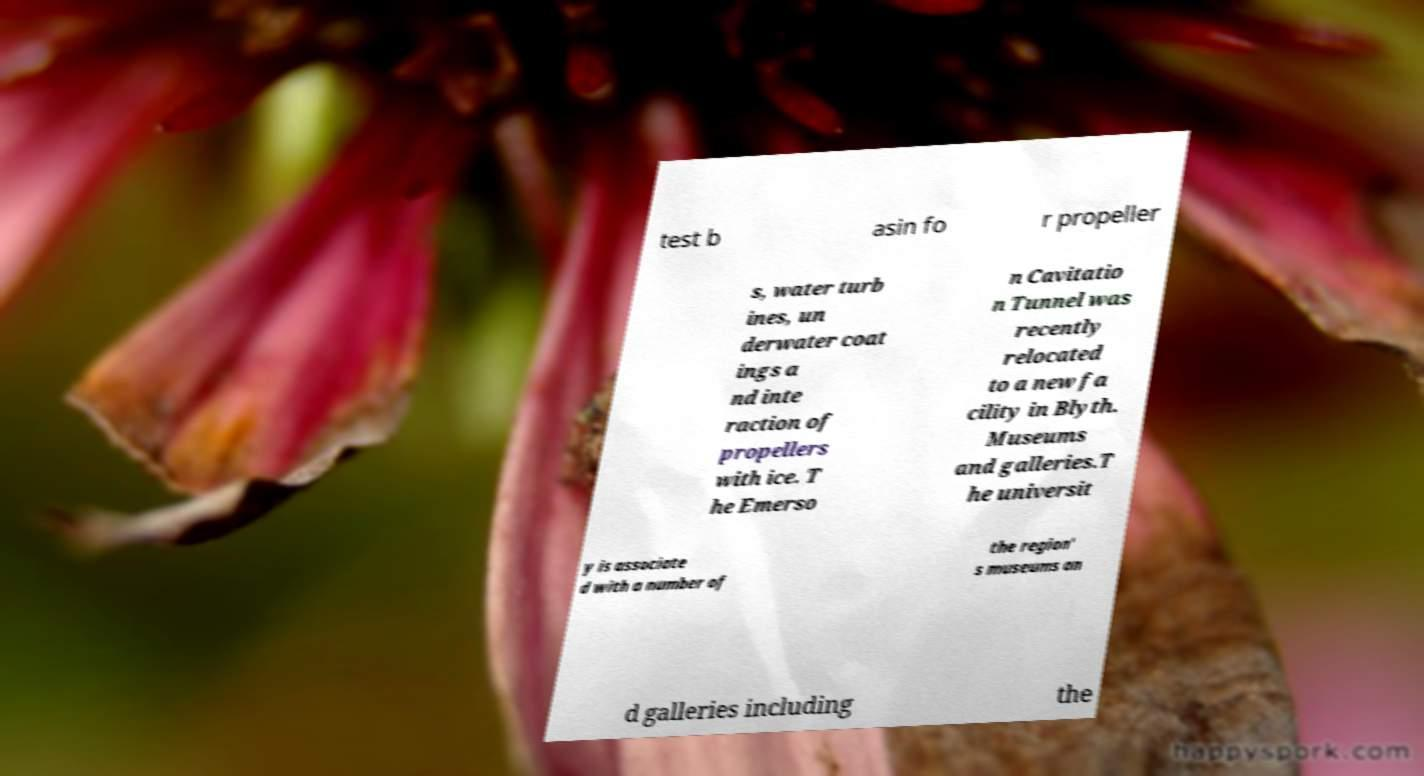For documentation purposes, I need the text within this image transcribed. Could you provide that? test b asin fo r propeller s, water turb ines, un derwater coat ings a nd inte raction of propellers with ice. T he Emerso n Cavitatio n Tunnel was recently relocated to a new fa cility in Blyth. Museums and galleries.T he universit y is associate d with a number of the region' s museums an d galleries including the 